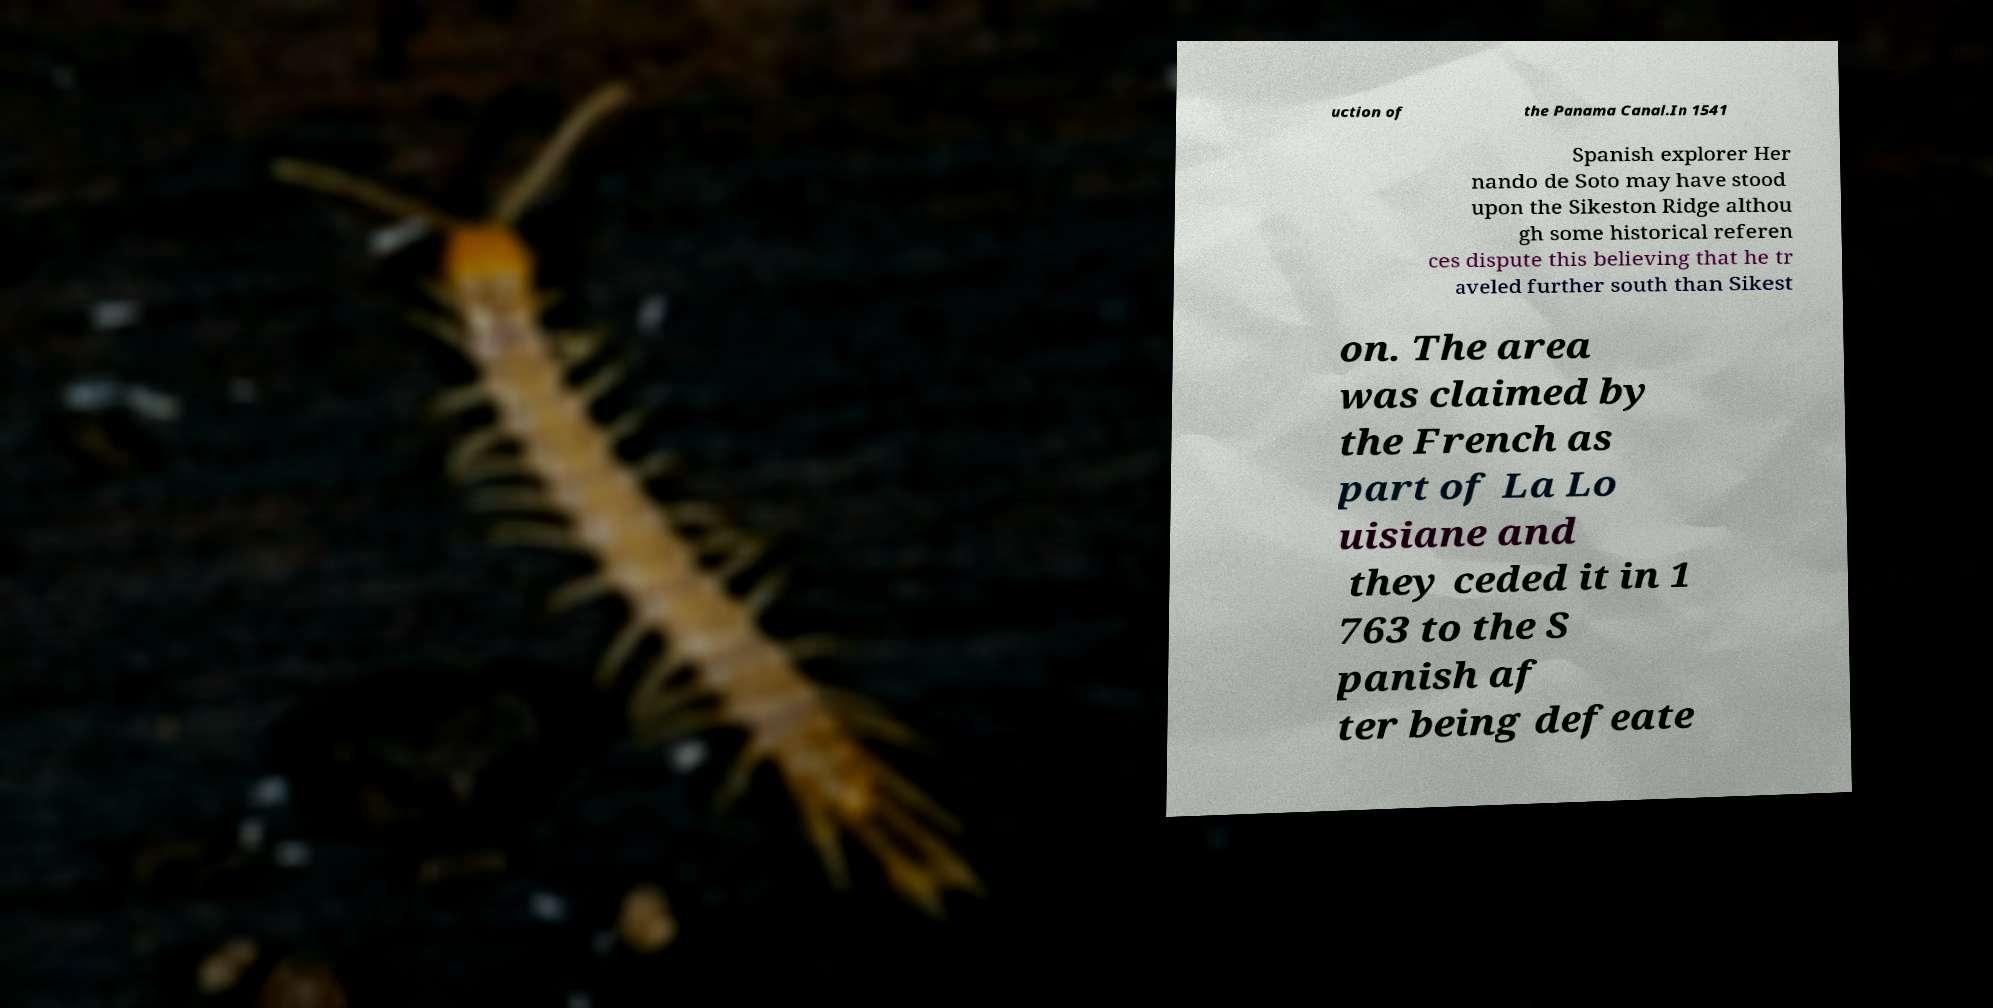Could you extract and type out the text from this image? uction of the Panama Canal.In 1541 Spanish explorer Her nando de Soto may have stood upon the Sikeston Ridge althou gh some historical referen ces dispute this believing that he tr aveled further south than Sikest on. The area was claimed by the French as part of La Lo uisiane and they ceded it in 1 763 to the S panish af ter being defeate 